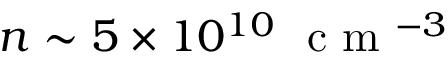Convert formula to latex. <formula><loc_0><loc_0><loc_500><loc_500>n \sim 5 \times 1 0 ^ { 1 0 } c m ^ { - 3 }</formula> 